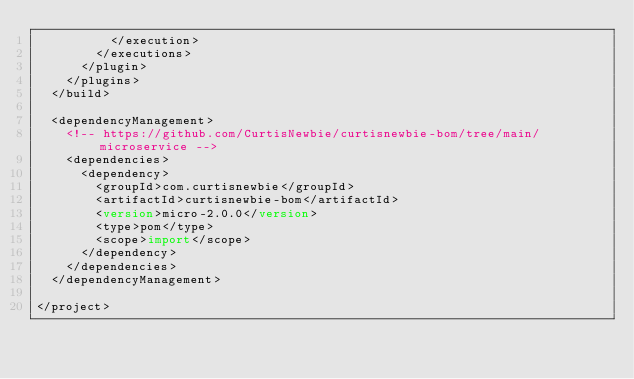<code> <loc_0><loc_0><loc_500><loc_500><_XML_>          </execution>
        </executions>
      </plugin>
    </plugins>
  </build>

  <dependencyManagement>
    <!-- https://github.com/CurtisNewbie/curtisnewbie-bom/tree/main/microservice -->
    <dependencies>
      <dependency>
        <groupId>com.curtisnewbie</groupId>
        <artifactId>curtisnewbie-bom</artifactId>
        <version>micro-2.0.0</version>
        <type>pom</type>
        <scope>import</scope>
      </dependency>
    </dependencies>
  </dependencyManagement>

</project></code> 